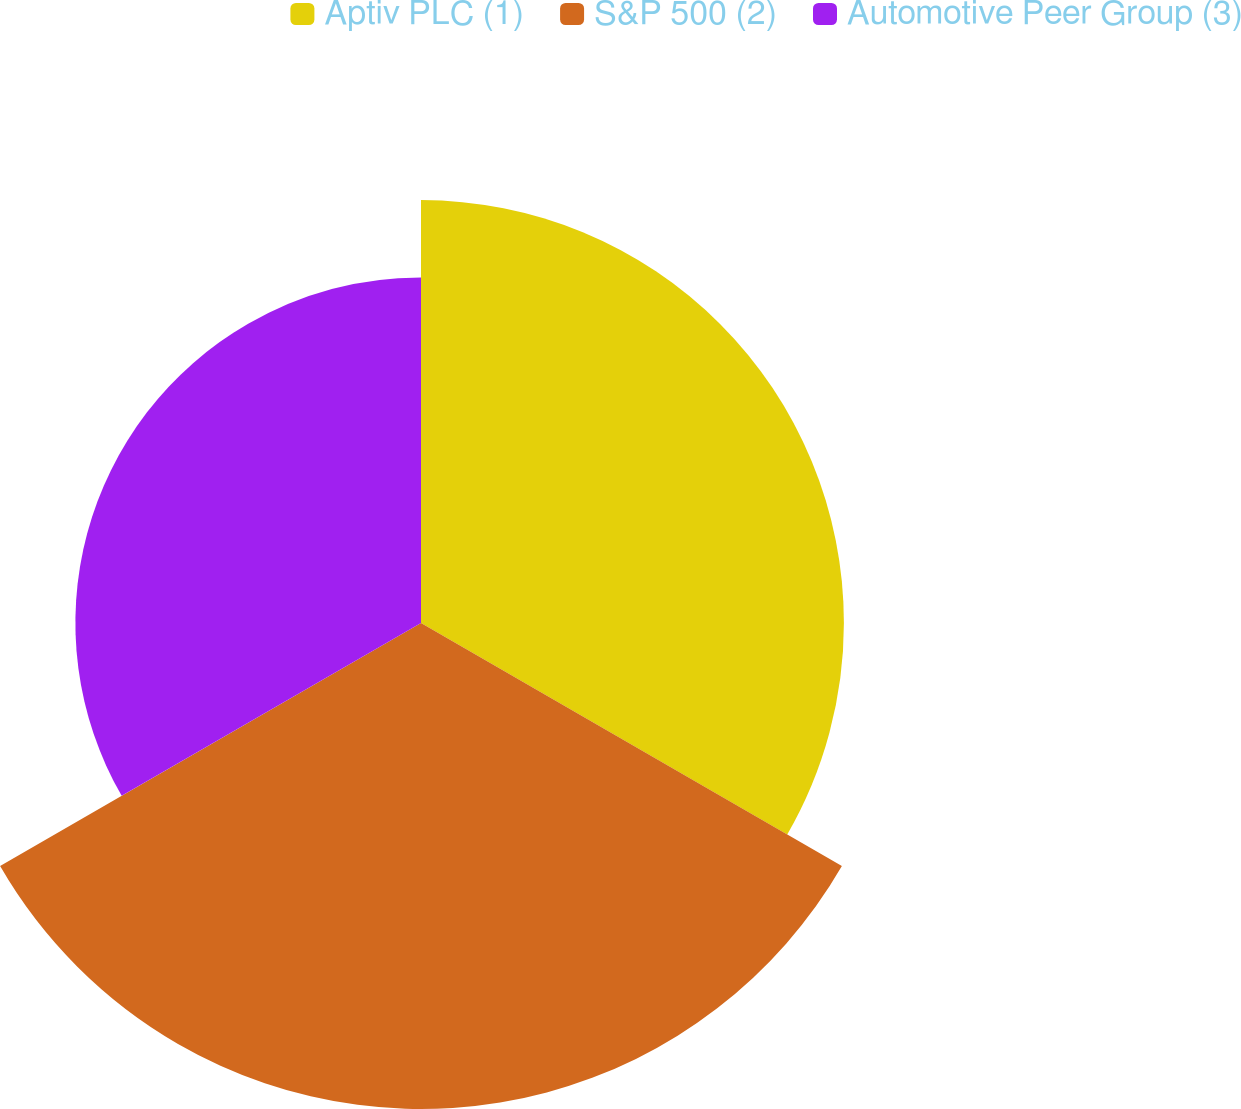Convert chart to OTSL. <chart><loc_0><loc_0><loc_500><loc_500><pie_chart><fcel>Aptiv PLC (1)<fcel>S&P 500 (2)<fcel>Automotive Peer Group (3)<nl><fcel>33.71%<fcel>38.74%<fcel>27.55%<nl></chart> 